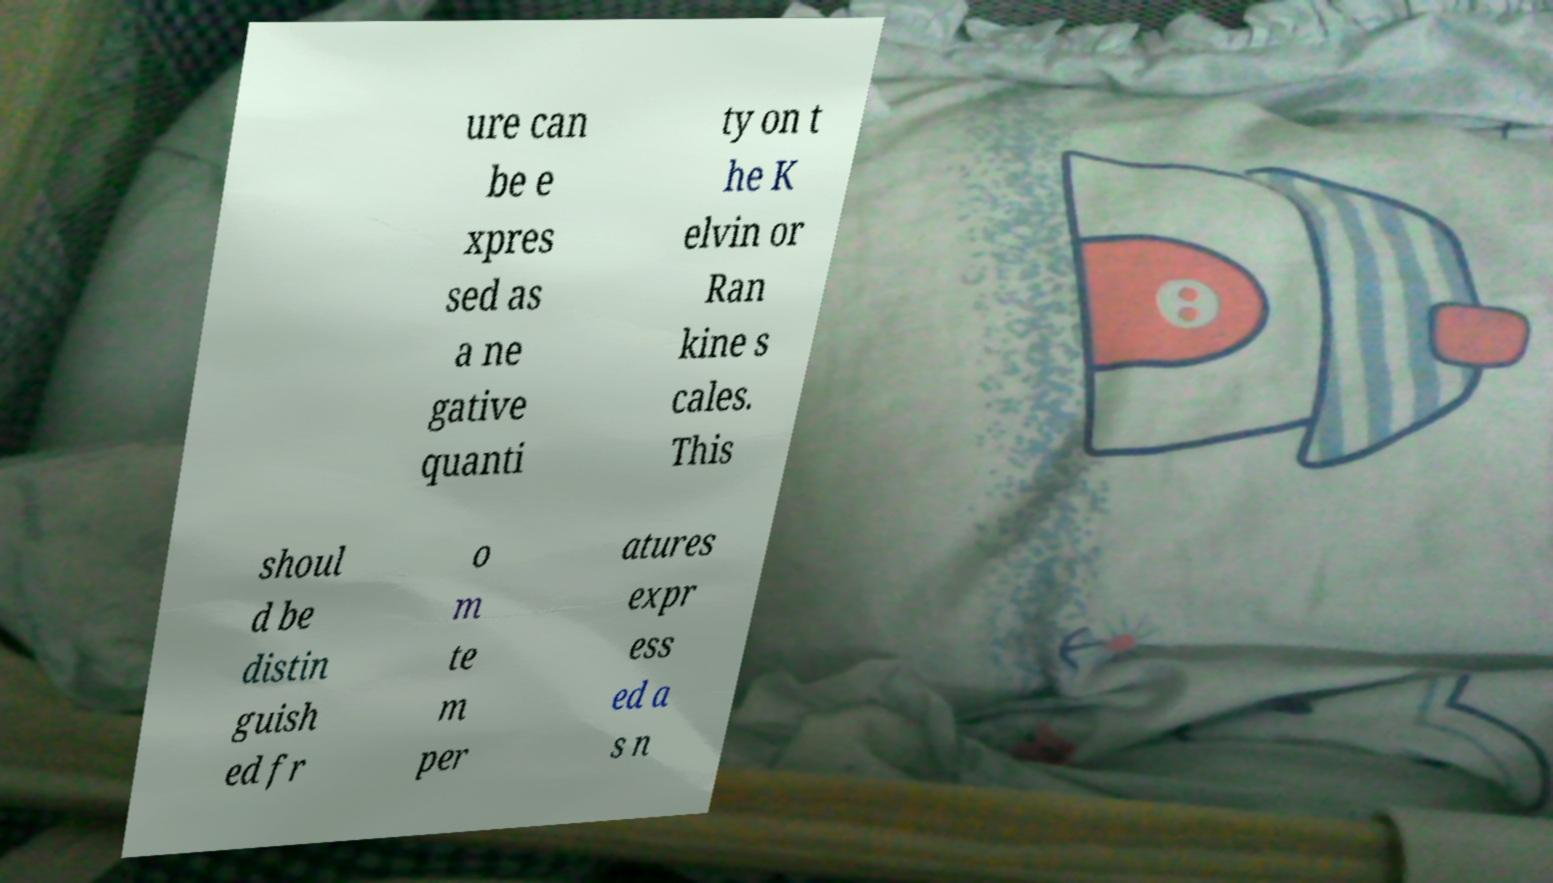Could you assist in decoding the text presented in this image and type it out clearly? ure can be e xpres sed as a ne gative quanti ty on t he K elvin or Ran kine s cales. This shoul d be distin guish ed fr o m te m per atures expr ess ed a s n 